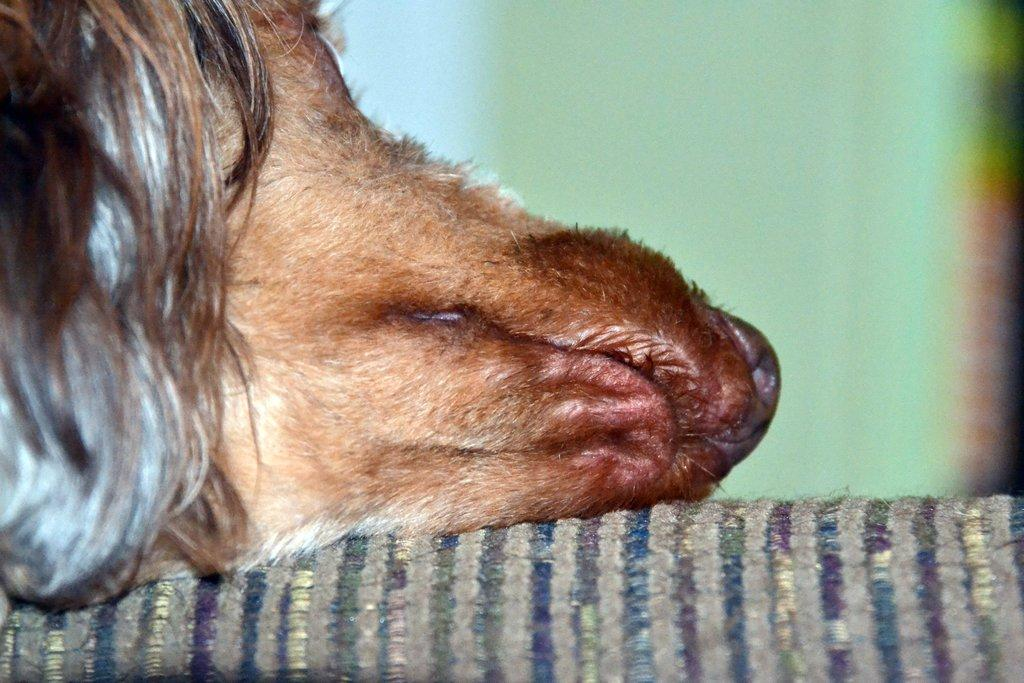What is depicted on the cloth in the image? There is an animal face on the cloth in the image. Can you describe the background of the image? The background of the image is blurry. What phase of the moon can be seen in the image? There is no moon visible in the image. What type of volleyball game is being played in the image? There is no volleyball game present in the image. 